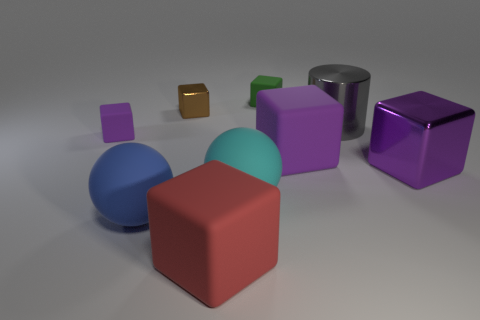Subtract all purple cubes. How many were subtracted if there are1purple cubes left? 2 Subtract all large rubber blocks. How many blocks are left? 4 Subtract all red balls. How many purple cubes are left? 3 Subtract 2 blocks. How many blocks are left? 4 Subtract all red blocks. How many blocks are left? 5 Add 1 large gray metallic cylinders. How many objects exist? 10 Subtract all spheres. How many objects are left? 7 Subtract all red cubes. Subtract all purple spheres. How many cubes are left? 5 Add 8 big cylinders. How many big cylinders are left? 9 Add 2 large brown cubes. How many large brown cubes exist? 2 